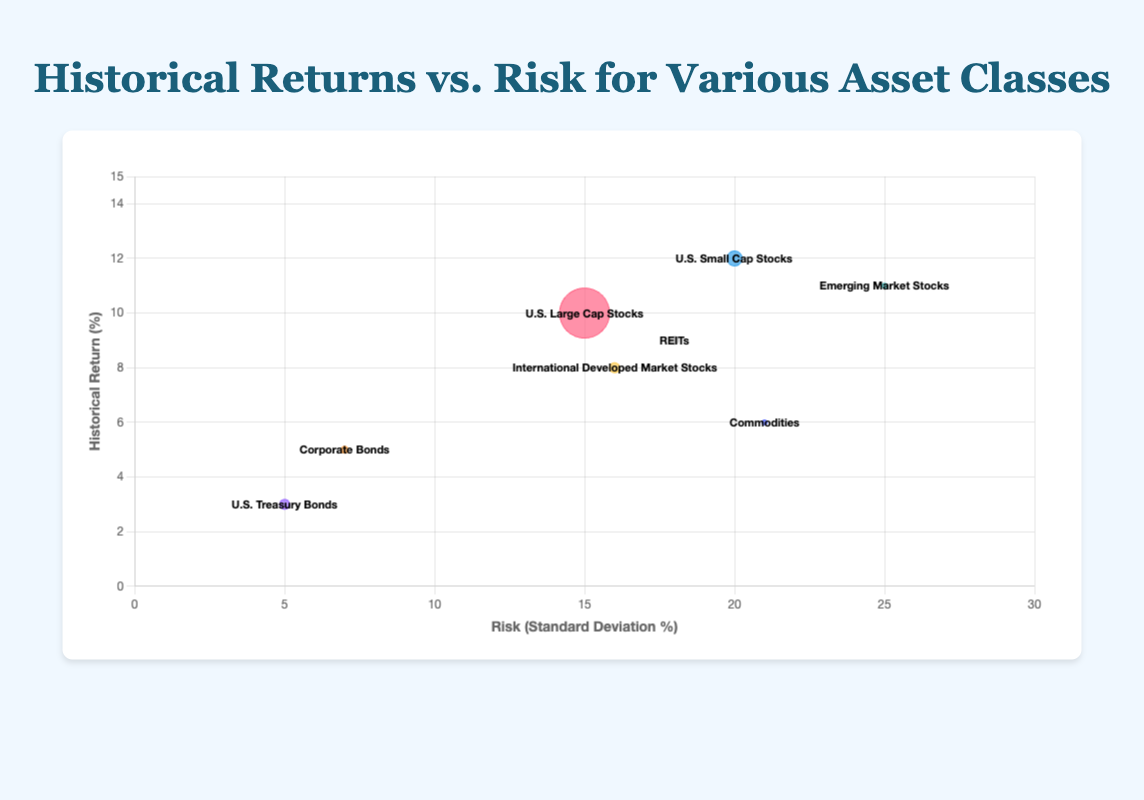What is the title of the chart? The chart's title is prominently displayed above the plot area, representing the overarching theme of the data visualized.
Answer: Historical Returns vs. Risk for Various Asset Classes What are the axes labeled as? The x-axis is labeled as "Risk (Standard Deviation %)" and the y-axis is labeled as "Historical Return (%)". These labels help in understanding what the axes represent in the context of the data.
Answer: Risk (Standard Deviation %) and Historical Return (%) How many asset classes are shown in the chart? Identify the number of unique labels or bubbles present in the chart. There are eight different bubbles, each representing a different asset class.
Answer: 8 Which asset class has the highest historical return? Locate the bubble that is positioned highest on the y-axis since it indicates the highest historical return. This bubble is labeled "U.S. Small Cap Stocks".
Answer: U.S. Small Cap Stocks What is the risk associated with U.S. Treasury Bonds? Find the bubble labeled "U.S. Treasury Bonds" and check its position on the x-axis, which gives the value of risk (Standard Deviation %).
Answer: 5.0 What is the portfolio share for Real Estate Investment Trusts (REITs)? Look for the bubble labeled "REITs" and interpret its size as the portfolio share percentage. According to the data, its radius correlates with a portfolio share of 8%.
Answer: 8% What are the differences in historical returns and risks between U.S. Small Cap Stocks and U.S. Large Cap Stocks? To find the difference in historical returns, subtract the historical return of U.S. Large Cap Stocks (10.0%) from that of U.S. Small Cap Stocks (12.0%). For risk, subtract the risk of U.S. Large Cap Stocks (15.0%) from that of U.S. Small Cap Stocks (20.0%).
Answer: Historical Return: 2%, Risk: 5% Which asset class has the highest risk, and what is its historical return? Locate the bubble farthest to the right on the x-axis since it indicates the highest risk. This bubble is labeled "Emerging Market Stocks". Then, check its position on the y-axis for its historical return.
Answer: Emerging Market Stocks, 11% Is there any asset class with a risk of less than 10%? Inspect the x-axis values and locate bubbles positioned left of the 10% risk mark, which includes U.S. Treasury Bonds (5%) and Corporate Bonds (7%).
Answer: Yes, U.S. Treasury Bonds and Corporate Bonds Which asset classes have a portfolio share of 5%? Identify the bubbles with a radius suggesting a 5% portfolio share. According to the legend, these correspond to Emerging Market Stocks and Commodities.
Answer: Emerging Market Stocks and Commodities 